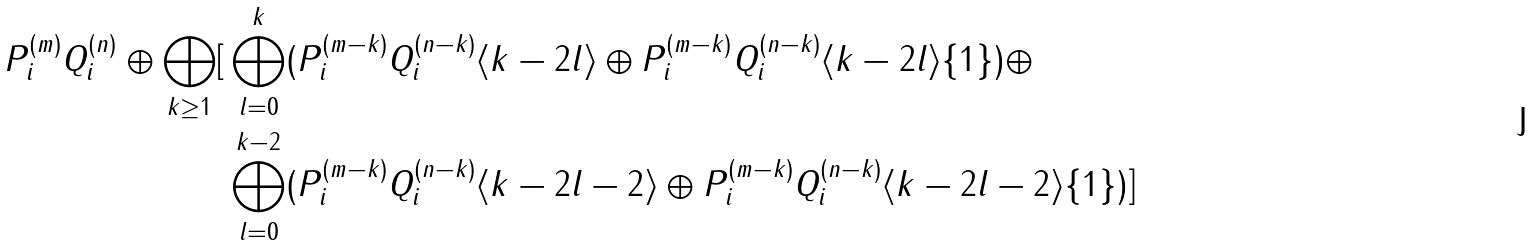Convert formula to latex. <formula><loc_0><loc_0><loc_500><loc_500>P _ { i } ^ { ( m ) } Q _ { i } ^ { ( n ) } \oplus \bigoplus _ { k \geq 1 } [ & \bigoplus _ { l = 0 } ^ { k } ( P _ { i } ^ { ( m - k ) } Q _ { i } ^ { ( n - k ) } \langle k - 2 l \rangle \oplus P _ { i } ^ { ( m - k ) } Q _ { i } ^ { ( n - k ) } \langle k - 2 l \rangle \{ 1 \} ) \oplus \\ & \bigoplus _ { l = 0 } ^ { k - 2 } ( P _ { i } ^ { ( m - k ) } Q _ { i } ^ { ( n - k ) } \langle k - 2 l - 2 \rangle \oplus P _ { i } ^ { ( m - k ) } Q _ { i } ^ { ( n - k ) } \langle k - 2 l - 2 \rangle \{ 1 \} ) ]</formula> 